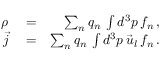<formula> <loc_0><loc_0><loc_500><loc_500>\begin{array} { r l r } { \rho } & = } & { \sum _ { n } q _ { n } \, \int d ^ { 3 } p \, f _ { n } \, , } \\ { \vec { j } } & = } & { \sum _ { n } q _ { n } \, \int d ^ { 3 } p \, \vec { u } _ { l } \, f _ { n } \, . } \end{array}</formula> 